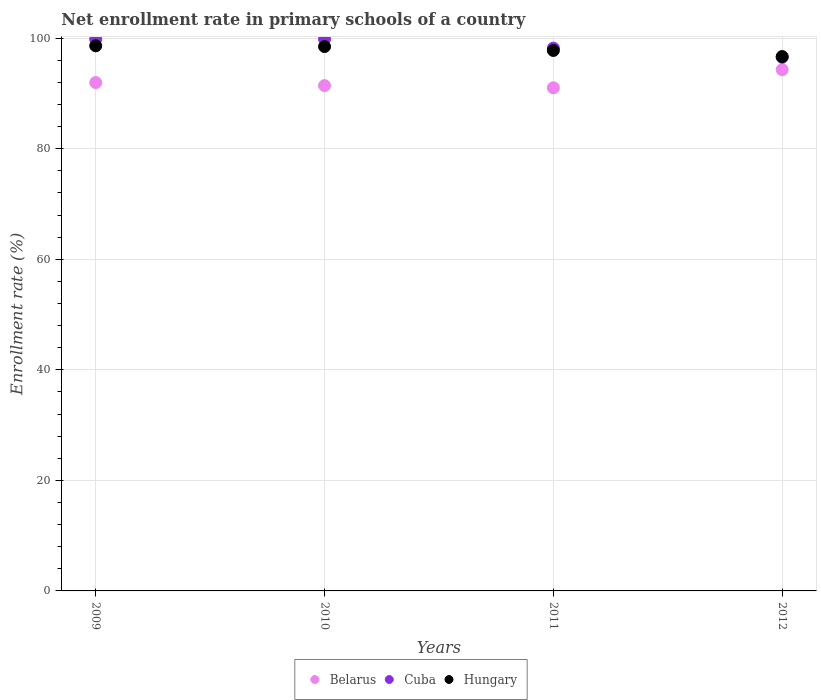Is the number of dotlines equal to the number of legend labels?
Offer a very short reply. Yes. What is the enrollment rate in primary schools in Belarus in 2011?
Make the answer very short. 91.02. Across all years, what is the maximum enrollment rate in primary schools in Hungary?
Make the answer very short. 98.6. Across all years, what is the minimum enrollment rate in primary schools in Cuba?
Provide a short and direct response. 96.53. In which year was the enrollment rate in primary schools in Cuba maximum?
Ensure brevity in your answer.  2010. What is the total enrollment rate in primary schools in Belarus in the graph?
Ensure brevity in your answer.  368.68. What is the difference between the enrollment rate in primary schools in Belarus in 2009 and that in 2010?
Offer a very short reply. 0.55. What is the difference between the enrollment rate in primary schools in Cuba in 2012 and the enrollment rate in primary schools in Hungary in 2010?
Make the answer very short. -1.94. What is the average enrollment rate in primary schools in Hungary per year?
Your answer should be compact. 97.87. In the year 2012, what is the difference between the enrollment rate in primary schools in Belarus and enrollment rate in primary schools in Hungary?
Offer a terse response. -2.36. What is the ratio of the enrollment rate in primary schools in Cuba in 2009 to that in 2011?
Offer a very short reply. 1.02. Is the enrollment rate in primary schools in Belarus in 2011 less than that in 2012?
Keep it short and to the point. Yes. What is the difference between the highest and the second highest enrollment rate in primary schools in Hungary?
Give a very brief answer. 0.13. What is the difference between the highest and the lowest enrollment rate in primary schools in Cuba?
Your answer should be compact. 3.3. Is the enrollment rate in primary schools in Hungary strictly greater than the enrollment rate in primary schools in Cuba over the years?
Your answer should be compact. No. Is the enrollment rate in primary schools in Hungary strictly less than the enrollment rate in primary schools in Belarus over the years?
Offer a terse response. No. How many dotlines are there?
Provide a succinct answer. 3. How many years are there in the graph?
Give a very brief answer. 4. Does the graph contain any zero values?
Your response must be concise. No. What is the title of the graph?
Give a very brief answer. Net enrollment rate in primary schools of a country. Does "Pacific island small states" appear as one of the legend labels in the graph?
Make the answer very short. No. What is the label or title of the X-axis?
Provide a short and direct response. Years. What is the label or title of the Y-axis?
Provide a succinct answer. Enrollment rate (%). What is the Enrollment rate (%) of Belarus in 2009?
Provide a succinct answer. 91.96. What is the Enrollment rate (%) of Cuba in 2009?
Provide a short and direct response. 99.8. What is the Enrollment rate (%) in Hungary in 2009?
Give a very brief answer. 98.6. What is the Enrollment rate (%) in Belarus in 2010?
Your answer should be very brief. 91.41. What is the Enrollment rate (%) in Cuba in 2010?
Your answer should be compact. 99.84. What is the Enrollment rate (%) in Hungary in 2010?
Provide a succinct answer. 98.47. What is the Enrollment rate (%) in Belarus in 2011?
Keep it short and to the point. 91.02. What is the Enrollment rate (%) in Cuba in 2011?
Provide a succinct answer. 98.18. What is the Enrollment rate (%) of Hungary in 2011?
Your answer should be compact. 97.77. What is the Enrollment rate (%) in Belarus in 2012?
Your answer should be compact. 94.3. What is the Enrollment rate (%) in Cuba in 2012?
Ensure brevity in your answer.  96.53. What is the Enrollment rate (%) in Hungary in 2012?
Your response must be concise. 96.66. Across all years, what is the maximum Enrollment rate (%) in Belarus?
Provide a short and direct response. 94.3. Across all years, what is the maximum Enrollment rate (%) of Cuba?
Your answer should be very brief. 99.84. Across all years, what is the maximum Enrollment rate (%) in Hungary?
Make the answer very short. 98.6. Across all years, what is the minimum Enrollment rate (%) in Belarus?
Offer a very short reply. 91.02. Across all years, what is the minimum Enrollment rate (%) of Cuba?
Provide a succinct answer. 96.53. Across all years, what is the minimum Enrollment rate (%) of Hungary?
Provide a succinct answer. 96.66. What is the total Enrollment rate (%) of Belarus in the graph?
Offer a very short reply. 368.68. What is the total Enrollment rate (%) of Cuba in the graph?
Keep it short and to the point. 394.35. What is the total Enrollment rate (%) in Hungary in the graph?
Provide a succinct answer. 391.5. What is the difference between the Enrollment rate (%) of Belarus in 2009 and that in 2010?
Your response must be concise. 0.55. What is the difference between the Enrollment rate (%) in Cuba in 2009 and that in 2010?
Offer a terse response. -0.04. What is the difference between the Enrollment rate (%) in Hungary in 2009 and that in 2010?
Your answer should be compact. 0.13. What is the difference between the Enrollment rate (%) of Belarus in 2009 and that in 2011?
Provide a succinct answer. 0.94. What is the difference between the Enrollment rate (%) in Cuba in 2009 and that in 2011?
Provide a succinct answer. 1.61. What is the difference between the Enrollment rate (%) of Hungary in 2009 and that in 2011?
Ensure brevity in your answer.  0.84. What is the difference between the Enrollment rate (%) in Belarus in 2009 and that in 2012?
Give a very brief answer. -2.34. What is the difference between the Enrollment rate (%) in Cuba in 2009 and that in 2012?
Make the answer very short. 3.26. What is the difference between the Enrollment rate (%) in Hungary in 2009 and that in 2012?
Provide a succinct answer. 1.94. What is the difference between the Enrollment rate (%) in Belarus in 2010 and that in 2011?
Provide a succinct answer. 0.39. What is the difference between the Enrollment rate (%) of Cuba in 2010 and that in 2011?
Offer a very short reply. 1.65. What is the difference between the Enrollment rate (%) in Hungary in 2010 and that in 2011?
Give a very brief answer. 0.7. What is the difference between the Enrollment rate (%) of Belarus in 2010 and that in 2012?
Make the answer very short. -2.89. What is the difference between the Enrollment rate (%) in Cuba in 2010 and that in 2012?
Make the answer very short. 3.3. What is the difference between the Enrollment rate (%) in Hungary in 2010 and that in 2012?
Provide a succinct answer. 1.81. What is the difference between the Enrollment rate (%) in Belarus in 2011 and that in 2012?
Your answer should be very brief. -3.28. What is the difference between the Enrollment rate (%) of Cuba in 2011 and that in 2012?
Your answer should be very brief. 1.65. What is the difference between the Enrollment rate (%) of Hungary in 2011 and that in 2012?
Provide a succinct answer. 1.11. What is the difference between the Enrollment rate (%) in Belarus in 2009 and the Enrollment rate (%) in Cuba in 2010?
Your response must be concise. -7.88. What is the difference between the Enrollment rate (%) of Belarus in 2009 and the Enrollment rate (%) of Hungary in 2010?
Offer a very short reply. -6.51. What is the difference between the Enrollment rate (%) of Cuba in 2009 and the Enrollment rate (%) of Hungary in 2010?
Keep it short and to the point. 1.33. What is the difference between the Enrollment rate (%) in Belarus in 2009 and the Enrollment rate (%) in Cuba in 2011?
Make the answer very short. -6.23. What is the difference between the Enrollment rate (%) in Belarus in 2009 and the Enrollment rate (%) in Hungary in 2011?
Make the answer very short. -5.81. What is the difference between the Enrollment rate (%) in Cuba in 2009 and the Enrollment rate (%) in Hungary in 2011?
Your answer should be compact. 2.03. What is the difference between the Enrollment rate (%) of Belarus in 2009 and the Enrollment rate (%) of Cuba in 2012?
Keep it short and to the point. -4.58. What is the difference between the Enrollment rate (%) of Cuba in 2009 and the Enrollment rate (%) of Hungary in 2012?
Offer a very short reply. 3.14. What is the difference between the Enrollment rate (%) in Belarus in 2010 and the Enrollment rate (%) in Cuba in 2011?
Make the answer very short. -6.78. What is the difference between the Enrollment rate (%) of Belarus in 2010 and the Enrollment rate (%) of Hungary in 2011?
Provide a short and direct response. -6.36. What is the difference between the Enrollment rate (%) of Cuba in 2010 and the Enrollment rate (%) of Hungary in 2011?
Your answer should be very brief. 2.07. What is the difference between the Enrollment rate (%) of Belarus in 2010 and the Enrollment rate (%) of Cuba in 2012?
Your response must be concise. -5.13. What is the difference between the Enrollment rate (%) of Belarus in 2010 and the Enrollment rate (%) of Hungary in 2012?
Keep it short and to the point. -5.25. What is the difference between the Enrollment rate (%) in Cuba in 2010 and the Enrollment rate (%) in Hungary in 2012?
Keep it short and to the point. 3.18. What is the difference between the Enrollment rate (%) of Belarus in 2011 and the Enrollment rate (%) of Cuba in 2012?
Provide a succinct answer. -5.52. What is the difference between the Enrollment rate (%) in Belarus in 2011 and the Enrollment rate (%) in Hungary in 2012?
Your answer should be very brief. -5.64. What is the difference between the Enrollment rate (%) in Cuba in 2011 and the Enrollment rate (%) in Hungary in 2012?
Make the answer very short. 1.53. What is the average Enrollment rate (%) of Belarus per year?
Provide a succinct answer. 92.17. What is the average Enrollment rate (%) of Cuba per year?
Provide a succinct answer. 98.59. What is the average Enrollment rate (%) in Hungary per year?
Make the answer very short. 97.87. In the year 2009, what is the difference between the Enrollment rate (%) in Belarus and Enrollment rate (%) in Cuba?
Keep it short and to the point. -7.84. In the year 2009, what is the difference between the Enrollment rate (%) of Belarus and Enrollment rate (%) of Hungary?
Keep it short and to the point. -6.64. In the year 2009, what is the difference between the Enrollment rate (%) of Cuba and Enrollment rate (%) of Hungary?
Your response must be concise. 1.19. In the year 2010, what is the difference between the Enrollment rate (%) of Belarus and Enrollment rate (%) of Cuba?
Keep it short and to the point. -8.43. In the year 2010, what is the difference between the Enrollment rate (%) of Belarus and Enrollment rate (%) of Hungary?
Offer a terse response. -7.06. In the year 2010, what is the difference between the Enrollment rate (%) in Cuba and Enrollment rate (%) in Hungary?
Make the answer very short. 1.37. In the year 2011, what is the difference between the Enrollment rate (%) in Belarus and Enrollment rate (%) in Cuba?
Offer a very short reply. -7.17. In the year 2011, what is the difference between the Enrollment rate (%) in Belarus and Enrollment rate (%) in Hungary?
Provide a succinct answer. -6.75. In the year 2011, what is the difference between the Enrollment rate (%) in Cuba and Enrollment rate (%) in Hungary?
Keep it short and to the point. 0.42. In the year 2012, what is the difference between the Enrollment rate (%) of Belarus and Enrollment rate (%) of Cuba?
Give a very brief answer. -2.24. In the year 2012, what is the difference between the Enrollment rate (%) in Belarus and Enrollment rate (%) in Hungary?
Your response must be concise. -2.36. In the year 2012, what is the difference between the Enrollment rate (%) of Cuba and Enrollment rate (%) of Hungary?
Keep it short and to the point. -0.13. What is the ratio of the Enrollment rate (%) in Belarus in 2009 to that in 2010?
Keep it short and to the point. 1.01. What is the ratio of the Enrollment rate (%) in Belarus in 2009 to that in 2011?
Make the answer very short. 1.01. What is the ratio of the Enrollment rate (%) in Cuba in 2009 to that in 2011?
Make the answer very short. 1.02. What is the ratio of the Enrollment rate (%) of Hungary in 2009 to that in 2011?
Your response must be concise. 1.01. What is the ratio of the Enrollment rate (%) of Belarus in 2009 to that in 2012?
Offer a very short reply. 0.98. What is the ratio of the Enrollment rate (%) of Cuba in 2009 to that in 2012?
Offer a terse response. 1.03. What is the ratio of the Enrollment rate (%) of Hungary in 2009 to that in 2012?
Give a very brief answer. 1.02. What is the ratio of the Enrollment rate (%) of Cuba in 2010 to that in 2011?
Offer a very short reply. 1.02. What is the ratio of the Enrollment rate (%) of Hungary in 2010 to that in 2011?
Provide a succinct answer. 1.01. What is the ratio of the Enrollment rate (%) of Belarus in 2010 to that in 2012?
Your answer should be compact. 0.97. What is the ratio of the Enrollment rate (%) in Cuba in 2010 to that in 2012?
Provide a succinct answer. 1.03. What is the ratio of the Enrollment rate (%) in Hungary in 2010 to that in 2012?
Provide a short and direct response. 1.02. What is the ratio of the Enrollment rate (%) of Belarus in 2011 to that in 2012?
Ensure brevity in your answer.  0.97. What is the ratio of the Enrollment rate (%) in Cuba in 2011 to that in 2012?
Your answer should be very brief. 1.02. What is the ratio of the Enrollment rate (%) in Hungary in 2011 to that in 2012?
Offer a terse response. 1.01. What is the difference between the highest and the second highest Enrollment rate (%) in Belarus?
Your response must be concise. 2.34. What is the difference between the highest and the second highest Enrollment rate (%) in Cuba?
Offer a terse response. 0.04. What is the difference between the highest and the second highest Enrollment rate (%) of Hungary?
Offer a very short reply. 0.13. What is the difference between the highest and the lowest Enrollment rate (%) of Belarus?
Make the answer very short. 3.28. What is the difference between the highest and the lowest Enrollment rate (%) in Cuba?
Your response must be concise. 3.3. What is the difference between the highest and the lowest Enrollment rate (%) in Hungary?
Give a very brief answer. 1.94. 